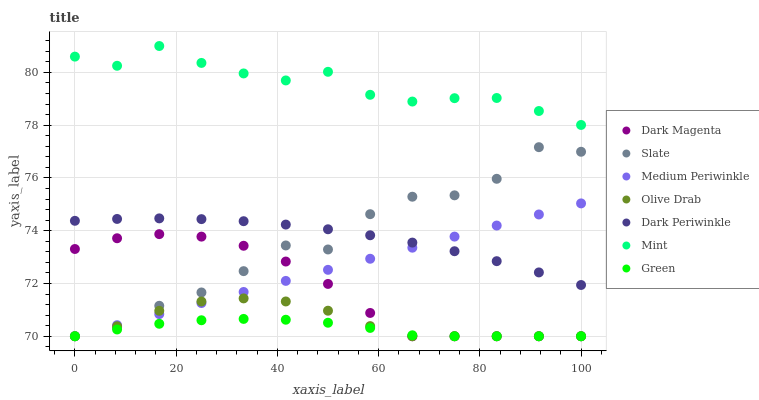Does Green have the minimum area under the curve?
Answer yes or no. Yes. Does Mint have the maximum area under the curve?
Answer yes or no. Yes. Does Slate have the minimum area under the curve?
Answer yes or no. No. Does Slate have the maximum area under the curve?
Answer yes or no. No. Is Medium Periwinkle the smoothest?
Answer yes or no. Yes. Is Slate the roughest?
Answer yes or no. Yes. Is Slate the smoothest?
Answer yes or no. No. Is Medium Periwinkle the roughest?
Answer yes or no. No. Does Dark Magenta have the lowest value?
Answer yes or no. Yes. Does Mint have the lowest value?
Answer yes or no. No. Does Mint have the highest value?
Answer yes or no. Yes. Does Slate have the highest value?
Answer yes or no. No. Is Olive Drab less than Dark Periwinkle?
Answer yes or no. Yes. Is Mint greater than Medium Periwinkle?
Answer yes or no. Yes. Does Medium Periwinkle intersect Olive Drab?
Answer yes or no. Yes. Is Medium Periwinkle less than Olive Drab?
Answer yes or no. No. Is Medium Periwinkle greater than Olive Drab?
Answer yes or no. No. Does Olive Drab intersect Dark Periwinkle?
Answer yes or no. No. 